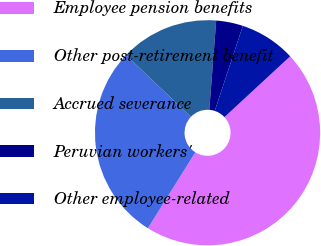<chart> <loc_0><loc_0><loc_500><loc_500><pie_chart><fcel>Employee pension benefits<fcel>Other post-retirement benefit<fcel>Accrued severance<fcel>Peruvian workers'<fcel>Other employee-related<nl><fcel>45.77%<fcel>28.23%<fcel>14.11%<fcel>3.85%<fcel>8.04%<nl></chart> 